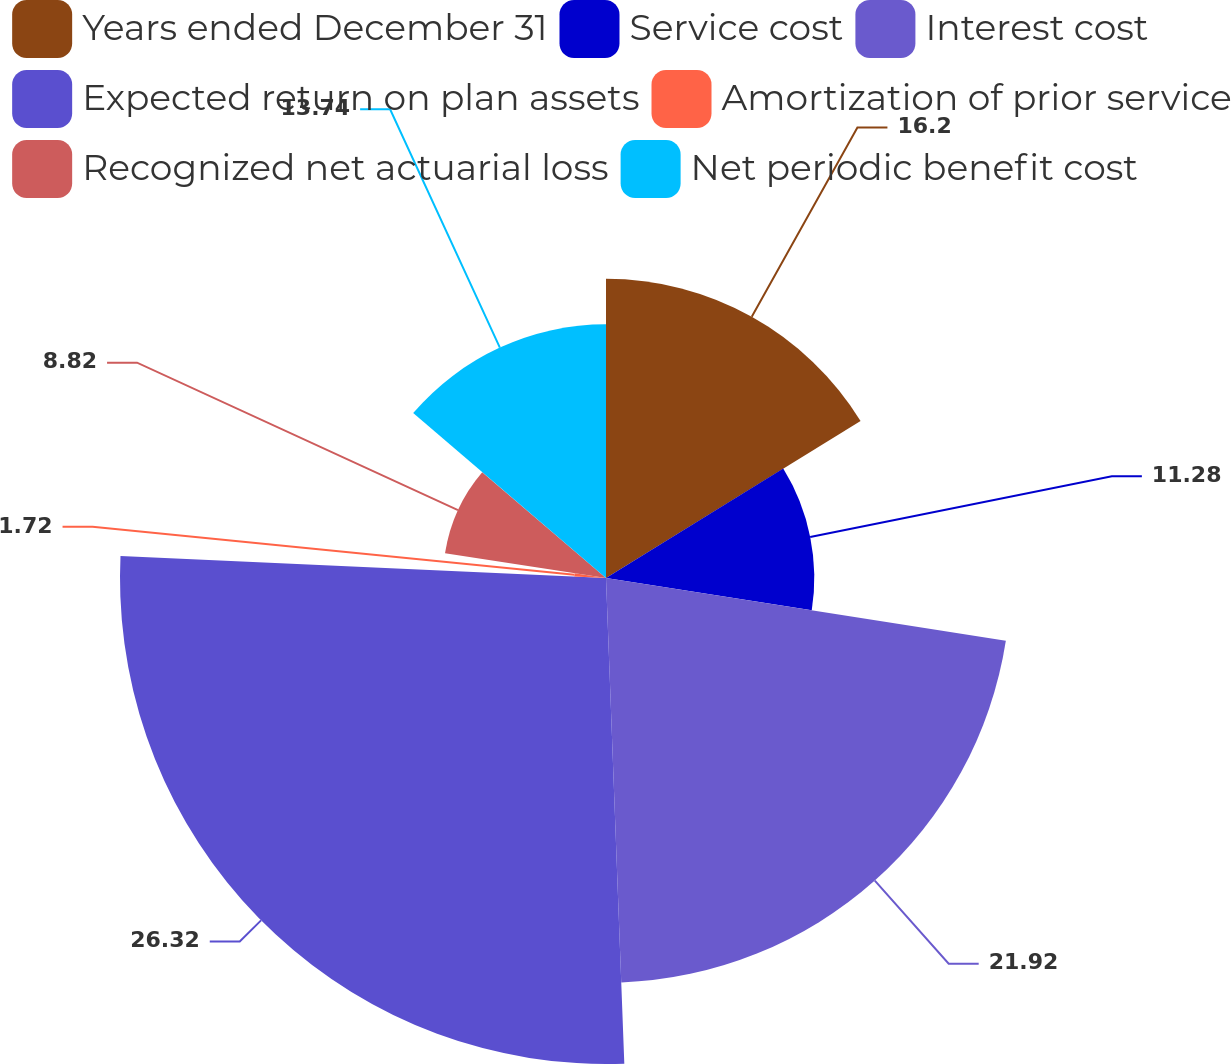Convert chart. <chart><loc_0><loc_0><loc_500><loc_500><pie_chart><fcel>Years ended December 31<fcel>Service cost<fcel>Interest cost<fcel>Expected return on plan assets<fcel>Amortization of prior service<fcel>Recognized net actuarial loss<fcel>Net periodic benefit cost<nl><fcel>16.2%<fcel>11.28%<fcel>21.92%<fcel>26.32%<fcel>1.72%<fcel>8.82%<fcel>13.74%<nl></chart> 